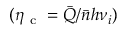Convert formula to latex. <formula><loc_0><loc_0><loc_500><loc_500>( \eta _ { c } = \bar { Q } / \bar { n } h \nu _ { i } )</formula> 